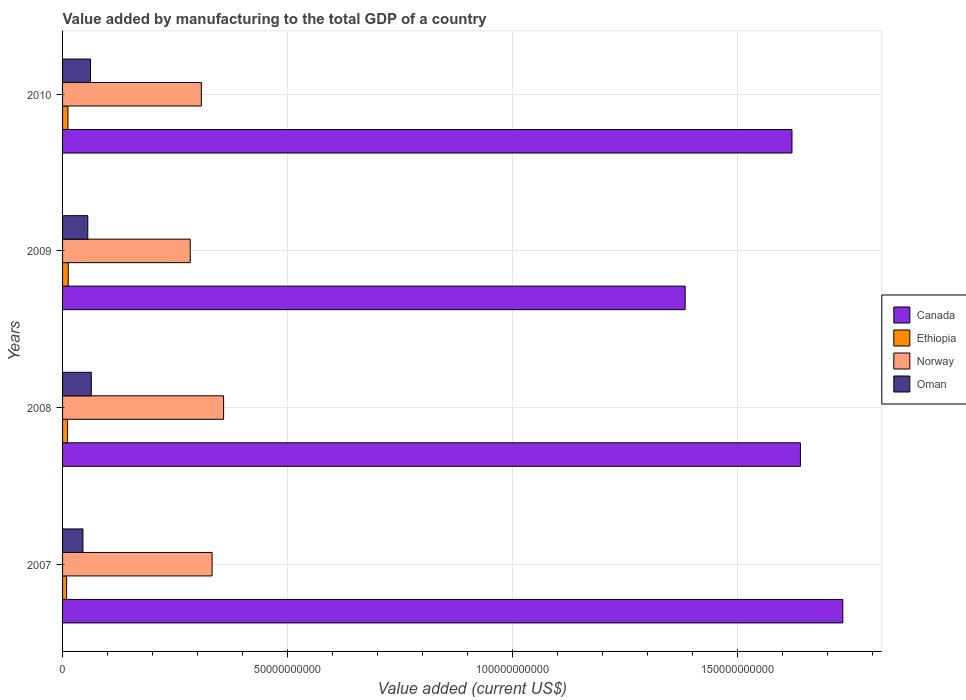How many groups of bars are there?
Ensure brevity in your answer.  4. Are the number of bars on each tick of the Y-axis equal?
Offer a very short reply. Yes. How many bars are there on the 1st tick from the top?
Offer a terse response. 4. How many bars are there on the 2nd tick from the bottom?
Offer a terse response. 4. What is the label of the 4th group of bars from the top?
Provide a succinct answer. 2007. What is the value added by manufacturing to the total GDP in Norway in 2010?
Ensure brevity in your answer.  3.08e+1. Across all years, what is the maximum value added by manufacturing to the total GDP in Canada?
Keep it short and to the point. 1.73e+11. Across all years, what is the minimum value added by manufacturing to the total GDP in Oman?
Make the answer very short. 4.53e+09. In which year was the value added by manufacturing to the total GDP in Ethiopia minimum?
Your answer should be compact. 2007. What is the total value added by manufacturing to the total GDP in Oman in the graph?
Offer a terse response. 2.27e+1. What is the difference between the value added by manufacturing to the total GDP in Ethiopia in 2007 and that in 2008?
Keep it short and to the point. -2.09e+08. What is the difference between the value added by manufacturing to the total GDP in Canada in 2010 and the value added by manufacturing to the total GDP in Ethiopia in 2007?
Offer a terse response. 1.61e+11. What is the average value added by manufacturing to the total GDP in Norway per year?
Provide a short and direct response. 3.21e+1. In the year 2009, what is the difference between the value added by manufacturing to the total GDP in Norway and value added by manufacturing to the total GDP in Ethiopia?
Provide a short and direct response. 2.71e+1. What is the ratio of the value added by manufacturing to the total GDP in Ethiopia in 2008 to that in 2010?
Give a very brief answer. 0.93. Is the value added by manufacturing to the total GDP in Norway in 2009 less than that in 2010?
Ensure brevity in your answer.  Yes. What is the difference between the highest and the second highest value added by manufacturing to the total GDP in Norway?
Provide a short and direct response. 2.56e+09. What is the difference between the highest and the lowest value added by manufacturing to the total GDP in Oman?
Your answer should be very brief. 1.86e+09. Is the sum of the value added by manufacturing to the total GDP in Norway in 2007 and 2009 greater than the maximum value added by manufacturing to the total GDP in Canada across all years?
Give a very brief answer. No. Is it the case that in every year, the sum of the value added by manufacturing to the total GDP in Oman and value added by manufacturing to the total GDP in Norway is greater than the sum of value added by manufacturing to the total GDP in Ethiopia and value added by manufacturing to the total GDP in Canada?
Your response must be concise. Yes. What does the 4th bar from the top in 2010 represents?
Your response must be concise. Canada. What does the 4th bar from the bottom in 2010 represents?
Your answer should be very brief. Oman. How many bars are there?
Keep it short and to the point. 16. What is the difference between two consecutive major ticks on the X-axis?
Offer a terse response. 5.00e+1. Are the values on the major ticks of X-axis written in scientific E-notation?
Your response must be concise. No. Does the graph contain grids?
Your answer should be compact. Yes. What is the title of the graph?
Give a very brief answer. Value added by manufacturing to the total GDP of a country. Does "Morocco" appear as one of the legend labels in the graph?
Give a very brief answer. No. What is the label or title of the X-axis?
Your answer should be compact. Value added (current US$). What is the label or title of the Y-axis?
Offer a terse response. Years. What is the Value added (current US$) in Canada in 2007?
Provide a short and direct response. 1.73e+11. What is the Value added (current US$) in Ethiopia in 2007?
Make the answer very short. 9.03e+08. What is the Value added (current US$) of Norway in 2007?
Provide a short and direct response. 3.32e+1. What is the Value added (current US$) of Oman in 2007?
Ensure brevity in your answer.  4.53e+09. What is the Value added (current US$) in Canada in 2008?
Ensure brevity in your answer.  1.64e+11. What is the Value added (current US$) of Ethiopia in 2008?
Ensure brevity in your answer.  1.11e+09. What is the Value added (current US$) of Norway in 2008?
Give a very brief answer. 3.58e+1. What is the Value added (current US$) of Oman in 2008?
Your answer should be very brief. 6.39e+09. What is the Value added (current US$) of Canada in 2009?
Your answer should be very brief. 1.38e+11. What is the Value added (current US$) in Ethiopia in 2009?
Give a very brief answer. 1.26e+09. What is the Value added (current US$) in Norway in 2009?
Provide a short and direct response. 2.84e+1. What is the Value added (current US$) of Oman in 2009?
Give a very brief answer. 5.60e+09. What is the Value added (current US$) in Canada in 2010?
Offer a very short reply. 1.62e+11. What is the Value added (current US$) in Ethiopia in 2010?
Provide a succinct answer. 1.19e+09. What is the Value added (current US$) of Norway in 2010?
Offer a very short reply. 3.08e+1. What is the Value added (current US$) in Oman in 2010?
Keep it short and to the point. 6.20e+09. Across all years, what is the maximum Value added (current US$) in Canada?
Offer a very short reply. 1.73e+11. Across all years, what is the maximum Value added (current US$) of Ethiopia?
Make the answer very short. 1.26e+09. Across all years, what is the maximum Value added (current US$) in Norway?
Make the answer very short. 3.58e+1. Across all years, what is the maximum Value added (current US$) in Oman?
Offer a terse response. 6.39e+09. Across all years, what is the minimum Value added (current US$) in Canada?
Keep it short and to the point. 1.38e+11. Across all years, what is the minimum Value added (current US$) in Ethiopia?
Your answer should be very brief. 9.03e+08. Across all years, what is the minimum Value added (current US$) of Norway?
Your response must be concise. 2.84e+1. Across all years, what is the minimum Value added (current US$) of Oman?
Your response must be concise. 4.53e+09. What is the total Value added (current US$) in Canada in the graph?
Ensure brevity in your answer.  6.38e+11. What is the total Value added (current US$) in Ethiopia in the graph?
Provide a short and direct response. 4.46e+09. What is the total Value added (current US$) in Norway in the graph?
Offer a very short reply. 1.28e+11. What is the total Value added (current US$) in Oman in the graph?
Offer a very short reply. 2.27e+1. What is the difference between the Value added (current US$) in Canada in 2007 and that in 2008?
Ensure brevity in your answer.  9.42e+09. What is the difference between the Value added (current US$) of Ethiopia in 2007 and that in 2008?
Provide a succinct answer. -2.09e+08. What is the difference between the Value added (current US$) in Norway in 2007 and that in 2008?
Ensure brevity in your answer.  -2.56e+09. What is the difference between the Value added (current US$) of Oman in 2007 and that in 2008?
Provide a short and direct response. -1.86e+09. What is the difference between the Value added (current US$) of Canada in 2007 and that in 2009?
Your response must be concise. 3.50e+1. What is the difference between the Value added (current US$) in Ethiopia in 2007 and that in 2009?
Provide a short and direct response. -3.56e+08. What is the difference between the Value added (current US$) of Norway in 2007 and that in 2009?
Provide a succinct answer. 4.85e+09. What is the difference between the Value added (current US$) of Oman in 2007 and that in 2009?
Give a very brief answer. -1.08e+09. What is the difference between the Value added (current US$) of Canada in 2007 and that in 2010?
Make the answer very short. 1.13e+1. What is the difference between the Value added (current US$) of Ethiopia in 2007 and that in 2010?
Offer a very short reply. -2.87e+08. What is the difference between the Value added (current US$) in Norway in 2007 and that in 2010?
Give a very brief answer. 2.39e+09. What is the difference between the Value added (current US$) in Oman in 2007 and that in 2010?
Offer a terse response. -1.68e+09. What is the difference between the Value added (current US$) of Canada in 2008 and that in 2009?
Your answer should be compact. 2.56e+1. What is the difference between the Value added (current US$) in Ethiopia in 2008 and that in 2009?
Your answer should be very brief. -1.47e+08. What is the difference between the Value added (current US$) in Norway in 2008 and that in 2009?
Ensure brevity in your answer.  7.41e+09. What is the difference between the Value added (current US$) in Oman in 2008 and that in 2009?
Offer a very short reply. 7.83e+08. What is the difference between the Value added (current US$) of Canada in 2008 and that in 2010?
Your answer should be compact. 1.87e+09. What is the difference between the Value added (current US$) in Ethiopia in 2008 and that in 2010?
Keep it short and to the point. -7.76e+07. What is the difference between the Value added (current US$) in Norway in 2008 and that in 2010?
Your answer should be very brief. 4.94e+09. What is the difference between the Value added (current US$) of Oman in 2008 and that in 2010?
Ensure brevity in your answer.  1.82e+08. What is the difference between the Value added (current US$) in Canada in 2009 and that in 2010?
Make the answer very short. -2.37e+1. What is the difference between the Value added (current US$) of Ethiopia in 2009 and that in 2010?
Provide a short and direct response. 6.91e+07. What is the difference between the Value added (current US$) in Norway in 2009 and that in 2010?
Offer a terse response. -2.46e+09. What is the difference between the Value added (current US$) of Oman in 2009 and that in 2010?
Provide a short and direct response. -6.01e+08. What is the difference between the Value added (current US$) in Canada in 2007 and the Value added (current US$) in Ethiopia in 2008?
Offer a very short reply. 1.72e+11. What is the difference between the Value added (current US$) in Canada in 2007 and the Value added (current US$) in Norway in 2008?
Give a very brief answer. 1.38e+11. What is the difference between the Value added (current US$) in Canada in 2007 and the Value added (current US$) in Oman in 2008?
Provide a short and direct response. 1.67e+11. What is the difference between the Value added (current US$) in Ethiopia in 2007 and the Value added (current US$) in Norway in 2008?
Your answer should be very brief. -3.49e+1. What is the difference between the Value added (current US$) in Ethiopia in 2007 and the Value added (current US$) in Oman in 2008?
Your answer should be compact. -5.48e+09. What is the difference between the Value added (current US$) of Norway in 2007 and the Value added (current US$) of Oman in 2008?
Your answer should be very brief. 2.68e+1. What is the difference between the Value added (current US$) in Canada in 2007 and the Value added (current US$) in Ethiopia in 2009?
Ensure brevity in your answer.  1.72e+11. What is the difference between the Value added (current US$) in Canada in 2007 and the Value added (current US$) in Norway in 2009?
Offer a very short reply. 1.45e+11. What is the difference between the Value added (current US$) in Canada in 2007 and the Value added (current US$) in Oman in 2009?
Your response must be concise. 1.68e+11. What is the difference between the Value added (current US$) of Ethiopia in 2007 and the Value added (current US$) of Norway in 2009?
Your answer should be very brief. -2.75e+1. What is the difference between the Value added (current US$) of Ethiopia in 2007 and the Value added (current US$) of Oman in 2009?
Offer a terse response. -4.70e+09. What is the difference between the Value added (current US$) of Norway in 2007 and the Value added (current US$) of Oman in 2009?
Give a very brief answer. 2.76e+1. What is the difference between the Value added (current US$) of Canada in 2007 and the Value added (current US$) of Ethiopia in 2010?
Provide a succinct answer. 1.72e+11. What is the difference between the Value added (current US$) of Canada in 2007 and the Value added (current US$) of Norway in 2010?
Provide a short and direct response. 1.43e+11. What is the difference between the Value added (current US$) in Canada in 2007 and the Value added (current US$) in Oman in 2010?
Keep it short and to the point. 1.67e+11. What is the difference between the Value added (current US$) in Ethiopia in 2007 and the Value added (current US$) in Norway in 2010?
Offer a very short reply. -2.99e+1. What is the difference between the Value added (current US$) in Ethiopia in 2007 and the Value added (current US$) in Oman in 2010?
Provide a succinct answer. -5.30e+09. What is the difference between the Value added (current US$) of Norway in 2007 and the Value added (current US$) of Oman in 2010?
Give a very brief answer. 2.70e+1. What is the difference between the Value added (current US$) of Canada in 2008 and the Value added (current US$) of Ethiopia in 2009?
Your answer should be very brief. 1.63e+11. What is the difference between the Value added (current US$) of Canada in 2008 and the Value added (current US$) of Norway in 2009?
Ensure brevity in your answer.  1.36e+11. What is the difference between the Value added (current US$) in Canada in 2008 and the Value added (current US$) in Oman in 2009?
Your answer should be very brief. 1.58e+11. What is the difference between the Value added (current US$) of Ethiopia in 2008 and the Value added (current US$) of Norway in 2009?
Ensure brevity in your answer.  -2.73e+1. What is the difference between the Value added (current US$) in Ethiopia in 2008 and the Value added (current US$) in Oman in 2009?
Keep it short and to the point. -4.49e+09. What is the difference between the Value added (current US$) in Norway in 2008 and the Value added (current US$) in Oman in 2009?
Offer a very short reply. 3.02e+1. What is the difference between the Value added (current US$) of Canada in 2008 and the Value added (current US$) of Ethiopia in 2010?
Provide a succinct answer. 1.63e+11. What is the difference between the Value added (current US$) in Canada in 2008 and the Value added (current US$) in Norway in 2010?
Keep it short and to the point. 1.33e+11. What is the difference between the Value added (current US$) of Canada in 2008 and the Value added (current US$) of Oman in 2010?
Offer a terse response. 1.58e+11. What is the difference between the Value added (current US$) of Ethiopia in 2008 and the Value added (current US$) of Norway in 2010?
Ensure brevity in your answer.  -2.97e+1. What is the difference between the Value added (current US$) of Ethiopia in 2008 and the Value added (current US$) of Oman in 2010?
Provide a short and direct response. -5.09e+09. What is the difference between the Value added (current US$) of Norway in 2008 and the Value added (current US$) of Oman in 2010?
Ensure brevity in your answer.  2.96e+1. What is the difference between the Value added (current US$) in Canada in 2009 and the Value added (current US$) in Ethiopia in 2010?
Give a very brief answer. 1.37e+11. What is the difference between the Value added (current US$) in Canada in 2009 and the Value added (current US$) in Norway in 2010?
Your answer should be very brief. 1.08e+11. What is the difference between the Value added (current US$) in Canada in 2009 and the Value added (current US$) in Oman in 2010?
Provide a succinct answer. 1.32e+11. What is the difference between the Value added (current US$) in Ethiopia in 2009 and the Value added (current US$) in Norway in 2010?
Make the answer very short. -2.96e+1. What is the difference between the Value added (current US$) of Ethiopia in 2009 and the Value added (current US$) of Oman in 2010?
Offer a terse response. -4.94e+09. What is the difference between the Value added (current US$) in Norway in 2009 and the Value added (current US$) in Oman in 2010?
Offer a terse response. 2.22e+1. What is the average Value added (current US$) in Canada per year?
Keep it short and to the point. 1.59e+11. What is the average Value added (current US$) in Ethiopia per year?
Make the answer very short. 1.12e+09. What is the average Value added (current US$) of Norway per year?
Your response must be concise. 3.21e+1. What is the average Value added (current US$) in Oman per year?
Your response must be concise. 5.68e+09. In the year 2007, what is the difference between the Value added (current US$) of Canada and Value added (current US$) of Ethiopia?
Offer a very short reply. 1.72e+11. In the year 2007, what is the difference between the Value added (current US$) in Canada and Value added (current US$) in Norway?
Offer a very short reply. 1.40e+11. In the year 2007, what is the difference between the Value added (current US$) of Canada and Value added (current US$) of Oman?
Give a very brief answer. 1.69e+11. In the year 2007, what is the difference between the Value added (current US$) in Ethiopia and Value added (current US$) in Norway?
Your response must be concise. -3.23e+1. In the year 2007, what is the difference between the Value added (current US$) of Ethiopia and Value added (current US$) of Oman?
Your answer should be compact. -3.62e+09. In the year 2007, what is the difference between the Value added (current US$) of Norway and Value added (current US$) of Oman?
Your answer should be very brief. 2.87e+1. In the year 2008, what is the difference between the Value added (current US$) in Canada and Value added (current US$) in Ethiopia?
Offer a terse response. 1.63e+11. In the year 2008, what is the difference between the Value added (current US$) of Canada and Value added (current US$) of Norway?
Provide a succinct answer. 1.28e+11. In the year 2008, what is the difference between the Value added (current US$) of Canada and Value added (current US$) of Oman?
Keep it short and to the point. 1.58e+11. In the year 2008, what is the difference between the Value added (current US$) in Ethiopia and Value added (current US$) in Norway?
Provide a succinct answer. -3.47e+1. In the year 2008, what is the difference between the Value added (current US$) in Ethiopia and Value added (current US$) in Oman?
Make the answer very short. -5.27e+09. In the year 2008, what is the difference between the Value added (current US$) of Norway and Value added (current US$) of Oman?
Your answer should be very brief. 2.94e+1. In the year 2009, what is the difference between the Value added (current US$) in Canada and Value added (current US$) in Ethiopia?
Provide a succinct answer. 1.37e+11. In the year 2009, what is the difference between the Value added (current US$) of Canada and Value added (current US$) of Norway?
Ensure brevity in your answer.  1.10e+11. In the year 2009, what is the difference between the Value added (current US$) in Canada and Value added (current US$) in Oman?
Your answer should be very brief. 1.33e+11. In the year 2009, what is the difference between the Value added (current US$) of Ethiopia and Value added (current US$) of Norway?
Give a very brief answer. -2.71e+1. In the year 2009, what is the difference between the Value added (current US$) of Ethiopia and Value added (current US$) of Oman?
Your answer should be very brief. -4.34e+09. In the year 2009, what is the difference between the Value added (current US$) in Norway and Value added (current US$) in Oman?
Provide a short and direct response. 2.28e+1. In the year 2010, what is the difference between the Value added (current US$) in Canada and Value added (current US$) in Ethiopia?
Provide a succinct answer. 1.61e+11. In the year 2010, what is the difference between the Value added (current US$) in Canada and Value added (current US$) in Norway?
Make the answer very short. 1.31e+11. In the year 2010, what is the difference between the Value added (current US$) of Canada and Value added (current US$) of Oman?
Your response must be concise. 1.56e+11. In the year 2010, what is the difference between the Value added (current US$) of Ethiopia and Value added (current US$) of Norway?
Your answer should be compact. -2.96e+1. In the year 2010, what is the difference between the Value added (current US$) of Ethiopia and Value added (current US$) of Oman?
Your answer should be compact. -5.01e+09. In the year 2010, what is the difference between the Value added (current US$) in Norway and Value added (current US$) in Oman?
Give a very brief answer. 2.46e+1. What is the ratio of the Value added (current US$) of Canada in 2007 to that in 2008?
Your response must be concise. 1.06. What is the ratio of the Value added (current US$) in Ethiopia in 2007 to that in 2008?
Your answer should be very brief. 0.81. What is the ratio of the Value added (current US$) of Norway in 2007 to that in 2008?
Your response must be concise. 0.93. What is the ratio of the Value added (current US$) in Oman in 2007 to that in 2008?
Make the answer very short. 0.71. What is the ratio of the Value added (current US$) of Canada in 2007 to that in 2009?
Your answer should be very brief. 1.25. What is the ratio of the Value added (current US$) of Ethiopia in 2007 to that in 2009?
Ensure brevity in your answer.  0.72. What is the ratio of the Value added (current US$) of Norway in 2007 to that in 2009?
Your answer should be compact. 1.17. What is the ratio of the Value added (current US$) in Oman in 2007 to that in 2009?
Provide a short and direct response. 0.81. What is the ratio of the Value added (current US$) of Canada in 2007 to that in 2010?
Give a very brief answer. 1.07. What is the ratio of the Value added (current US$) in Ethiopia in 2007 to that in 2010?
Provide a succinct answer. 0.76. What is the ratio of the Value added (current US$) of Norway in 2007 to that in 2010?
Offer a terse response. 1.08. What is the ratio of the Value added (current US$) of Oman in 2007 to that in 2010?
Keep it short and to the point. 0.73. What is the ratio of the Value added (current US$) of Canada in 2008 to that in 2009?
Make the answer very short. 1.19. What is the ratio of the Value added (current US$) in Ethiopia in 2008 to that in 2009?
Make the answer very short. 0.88. What is the ratio of the Value added (current US$) of Norway in 2008 to that in 2009?
Make the answer very short. 1.26. What is the ratio of the Value added (current US$) in Oman in 2008 to that in 2009?
Your response must be concise. 1.14. What is the ratio of the Value added (current US$) of Canada in 2008 to that in 2010?
Keep it short and to the point. 1.01. What is the ratio of the Value added (current US$) of Ethiopia in 2008 to that in 2010?
Your answer should be compact. 0.93. What is the ratio of the Value added (current US$) in Norway in 2008 to that in 2010?
Keep it short and to the point. 1.16. What is the ratio of the Value added (current US$) of Oman in 2008 to that in 2010?
Provide a short and direct response. 1.03. What is the ratio of the Value added (current US$) in Canada in 2009 to that in 2010?
Give a very brief answer. 0.85. What is the ratio of the Value added (current US$) in Ethiopia in 2009 to that in 2010?
Offer a very short reply. 1.06. What is the ratio of the Value added (current US$) of Norway in 2009 to that in 2010?
Offer a very short reply. 0.92. What is the ratio of the Value added (current US$) of Oman in 2009 to that in 2010?
Keep it short and to the point. 0.9. What is the difference between the highest and the second highest Value added (current US$) of Canada?
Your answer should be very brief. 9.42e+09. What is the difference between the highest and the second highest Value added (current US$) in Ethiopia?
Provide a succinct answer. 6.91e+07. What is the difference between the highest and the second highest Value added (current US$) of Norway?
Give a very brief answer. 2.56e+09. What is the difference between the highest and the second highest Value added (current US$) in Oman?
Offer a very short reply. 1.82e+08. What is the difference between the highest and the lowest Value added (current US$) in Canada?
Make the answer very short. 3.50e+1. What is the difference between the highest and the lowest Value added (current US$) in Ethiopia?
Provide a short and direct response. 3.56e+08. What is the difference between the highest and the lowest Value added (current US$) of Norway?
Offer a terse response. 7.41e+09. What is the difference between the highest and the lowest Value added (current US$) of Oman?
Provide a succinct answer. 1.86e+09. 